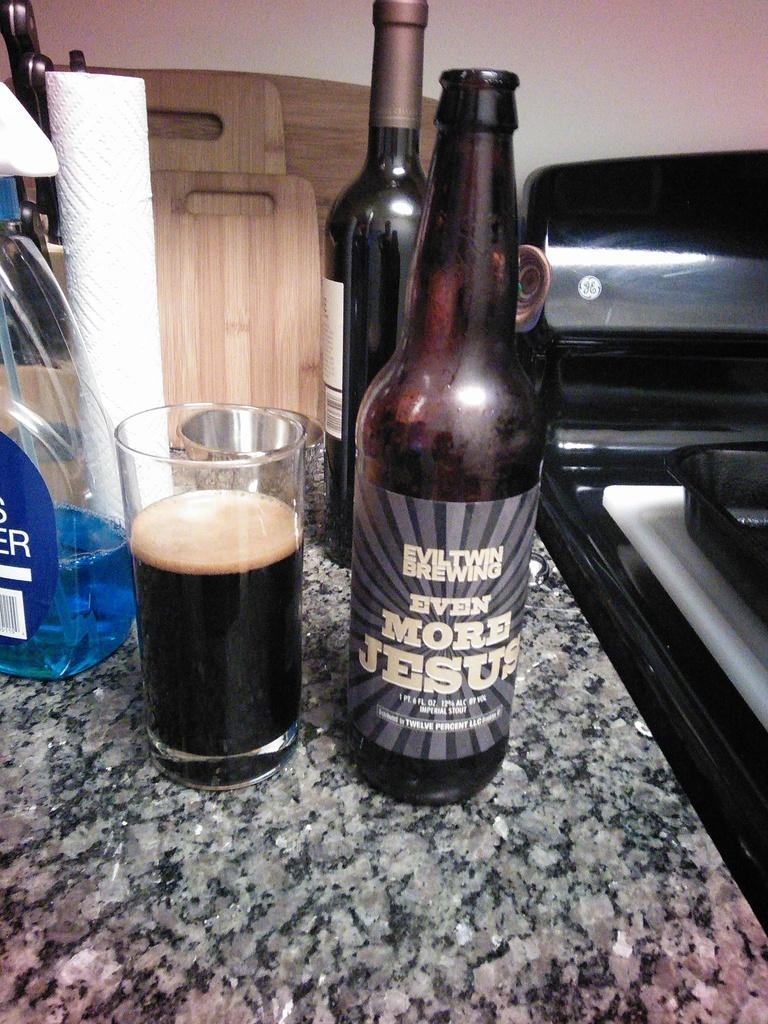Provide a one-sentence caption for the provided image. A bottle of stout beer by Evil Twin Brewing has been poured into a glass that is sitting next to a bottle of blue glass cleaner. 